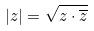Convert formula to latex. <formula><loc_0><loc_0><loc_500><loc_500>| z | = \sqrt { z \cdot \overline { z } }</formula> 